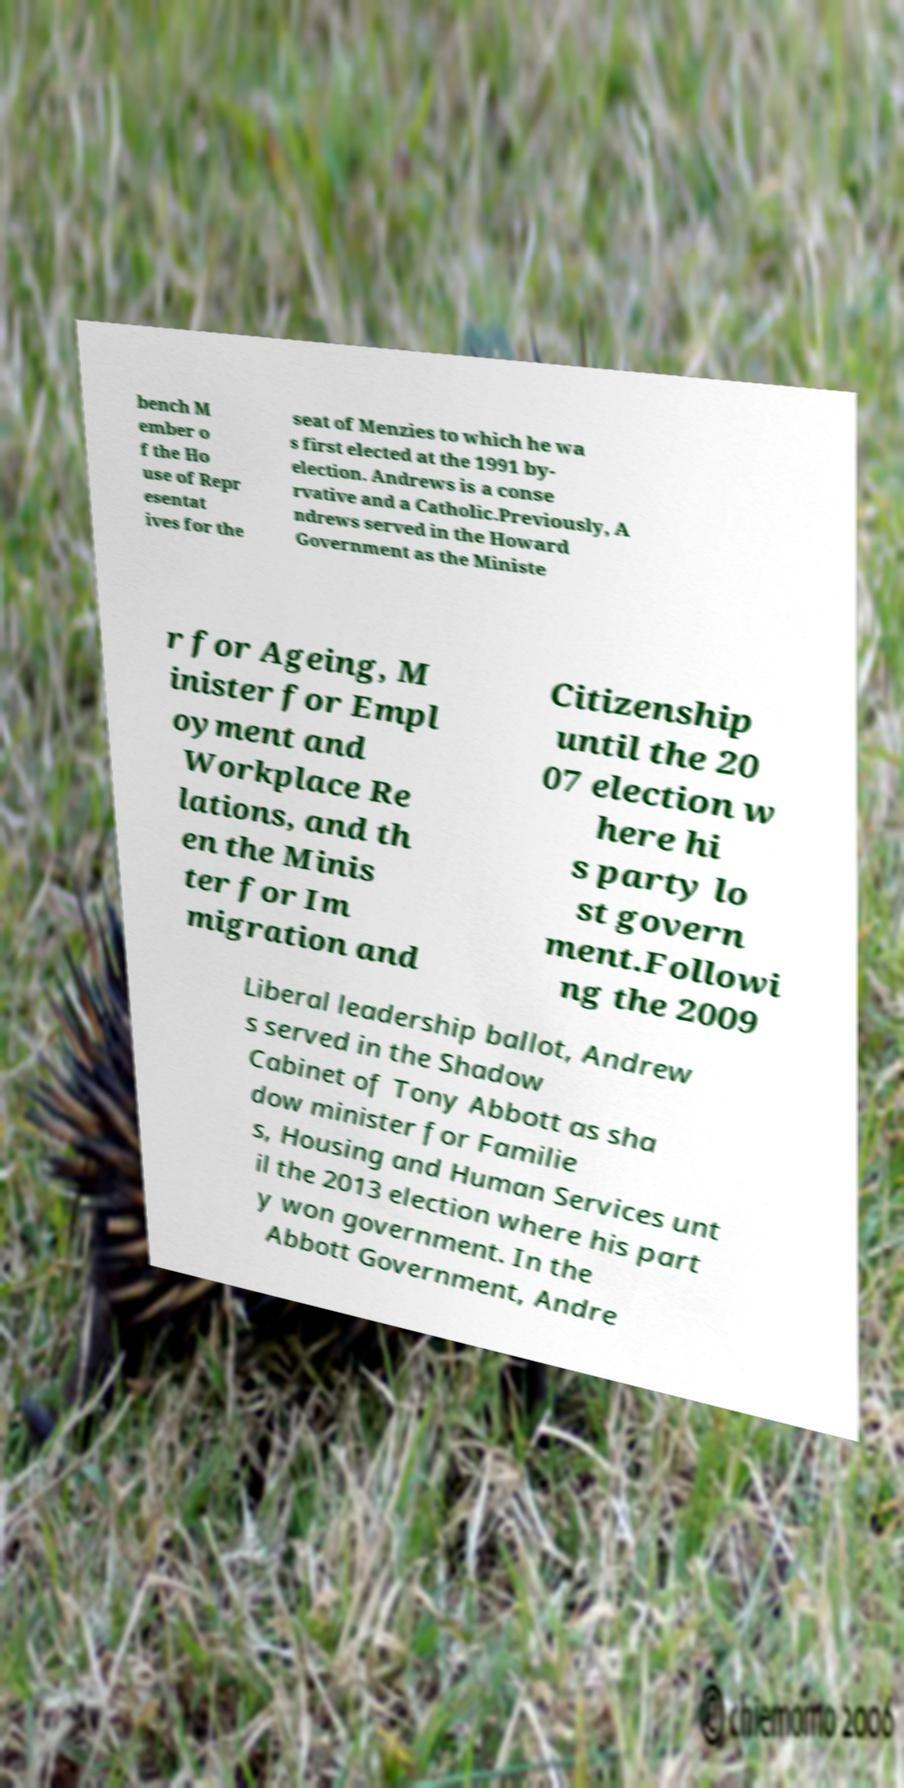Can you read and provide the text displayed in the image?This photo seems to have some interesting text. Can you extract and type it out for me? bench M ember o f the Ho use of Repr esentat ives for the seat of Menzies to which he wa s first elected at the 1991 by- election. Andrews is a conse rvative and a Catholic.Previously, A ndrews served in the Howard Government as the Ministe r for Ageing, M inister for Empl oyment and Workplace Re lations, and th en the Minis ter for Im migration and Citizenship until the 20 07 election w here hi s party lo st govern ment.Followi ng the 2009 Liberal leadership ballot, Andrew s served in the Shadow Cabinet of Tony Abbott as sha dow minister for Familie s, Housing and Human Services unt il the 2013 election where his part y won government. In the Abbott Government, Andre 